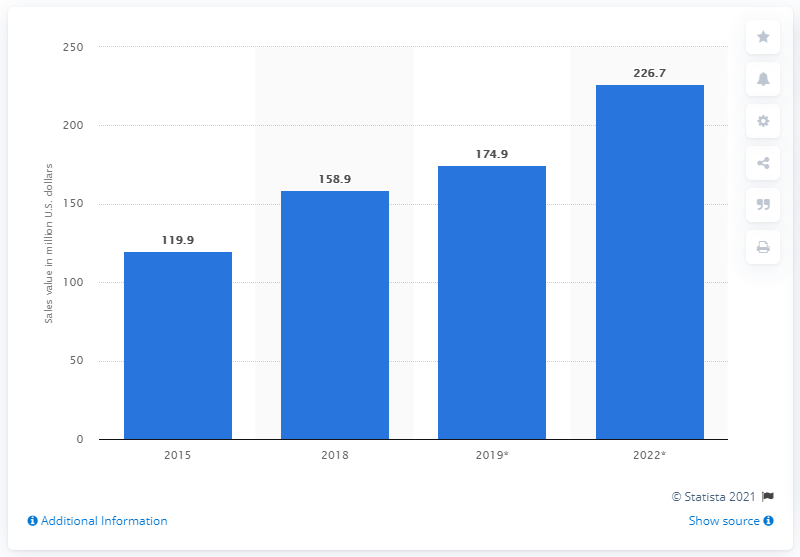Point out several critical features in this image. The retail sales value of meat substitutes in 2022 was 226.7 million dollars. In 2018, the retail sales value of meat substitutes in the United States was $158.9 million. 